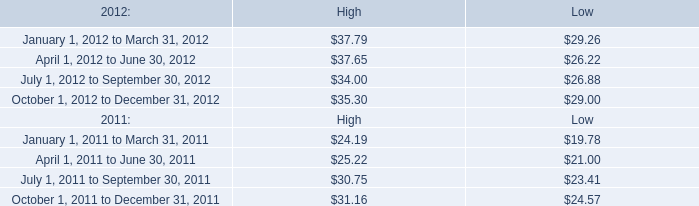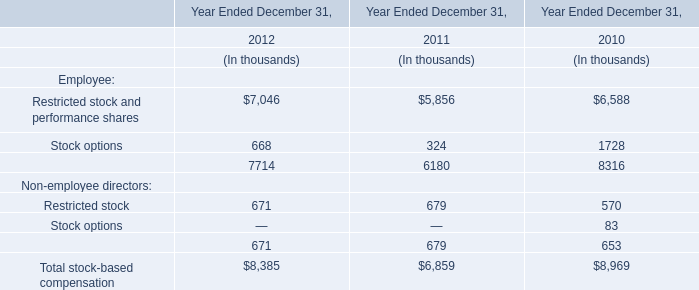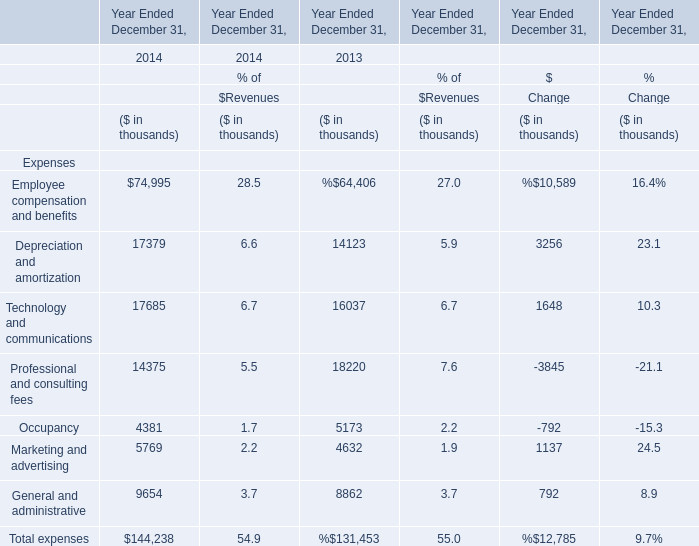by how much did the low of mktx stock increase from 2011 to march 2012? 
Computations: ((29.26 - 24.57) / 24.57)
Answer: 0.19088. What is the sum of the Occupancy in the years where Professional and consulting fees is positive? (in thousand) 
Computations: (4381 + 5173)
Answer: 9554.0. 